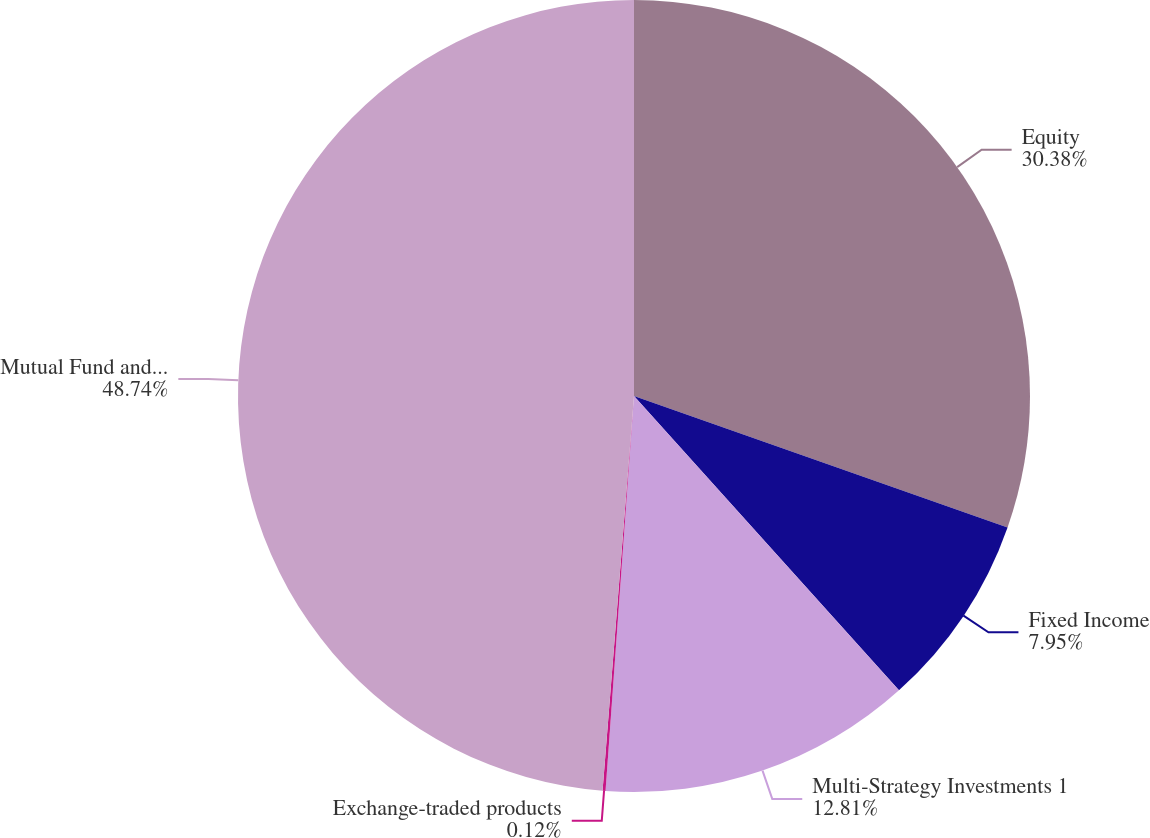<chart> <loc_0><loc_0><loc_500><loc_500><pie_chart><fcel>Equity<fcel>Fixed Income<fcel>Multi-Strategy Investments 1<fcel>Exchange-traded products<fcel>Mutual Fund and ETP AUM<nl><fcel>30.38%<fcel>7.95%<fcel>12.81%<fcel>0.12%<fcel>48.73%<nl></chart> 